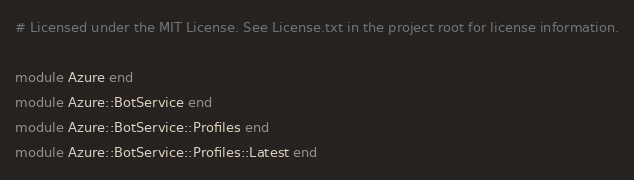Convert code to text. <code><loc_0><loc_0><loc_500><loc_500><_Ruby_># Licensed under the MIT License. See License.txt in the project root for license information.

module Azure end
module Azure::BotService end
module Azure::BotService::Profiles end
module Azure::BotService::Profiles::Latest end
</code> 